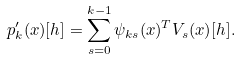<formula> <loc_0><loc_0><loc_500><loc_500>p _ { k } ^ { \prime } ( x ) [ h ] = \sum _ { s = 0 } ^ { k - 1 } \psi _ { k s } ( x ) ^ { T } V _ { s } ( x ) [ h ] .</formula> 